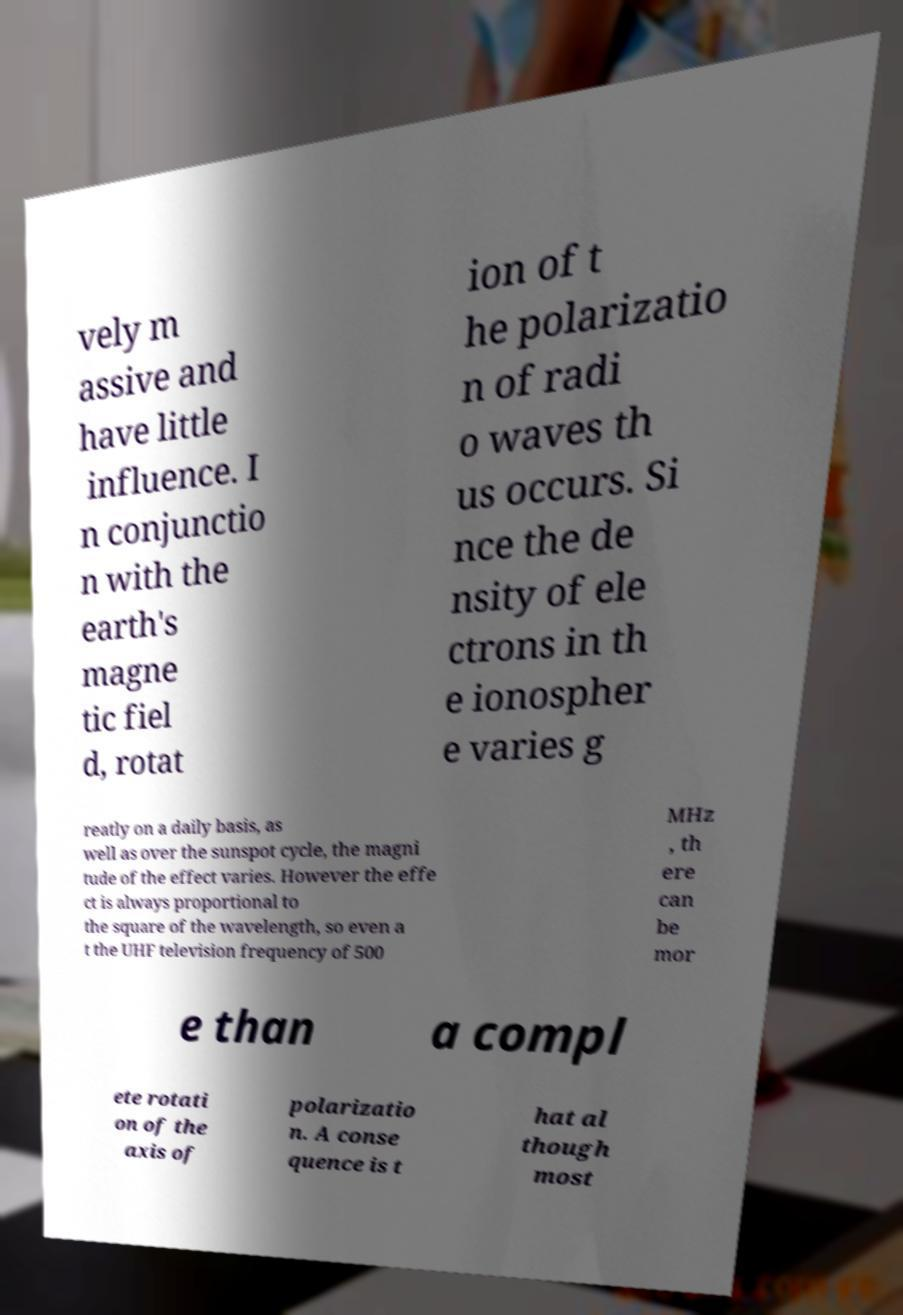Can you read and provide the text displayed in the image?This photo seems to have some interesting text. Can you extract and type it out for me? vely m assive and have little influence. I n conjunctio n with the earth's magne tic fiel d, rotat ion of t he polarizatio n of radi o waves th us occurs. Si nce the de nsity of ele ctrons in th e ionospher e varies g reatly on a daily basis, as well as over the sunspot cycle, the magni tude of the effect varies. However the effe ct is always proportional to the square of the wavelength, so even a t the UHF television frequency of 500 MHz , th ere can be mor e than a compl ete rotati on of the axis of polarizatio n. A conse quence is t hat al though most 